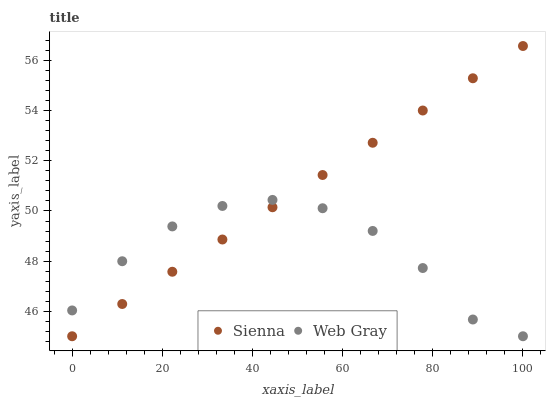Does Web Gray have the minimum area under the curve?
Answer yes or no. Yes. Does Sienna have the maximum area under the curve?
Answer yes or no. Yes. Does Web Gray have the maximum area under the curve?
Answer yes or no. No. Is Sienna the smoothest?
Answer yes or no. Yes. Is Web Gray the roughest?
Answer yes or no. Yes. Is Web Gray the smoothest?
Answer yes or no. No. Does Sienna have the lowest value?
Answer yes or no. Yes. Does Sienna have the highest value?
Answer yes or no. Yes. Does Web Gray have the highest value?
Answer yes or no. No. Does Web Gray intersect Sienna?
Answer yes or no. Yes. Is Web Gray less than Sienna?
Answer yes or no. No. Is Web Gray greater than Sienna?
Answer yes or no. No. 